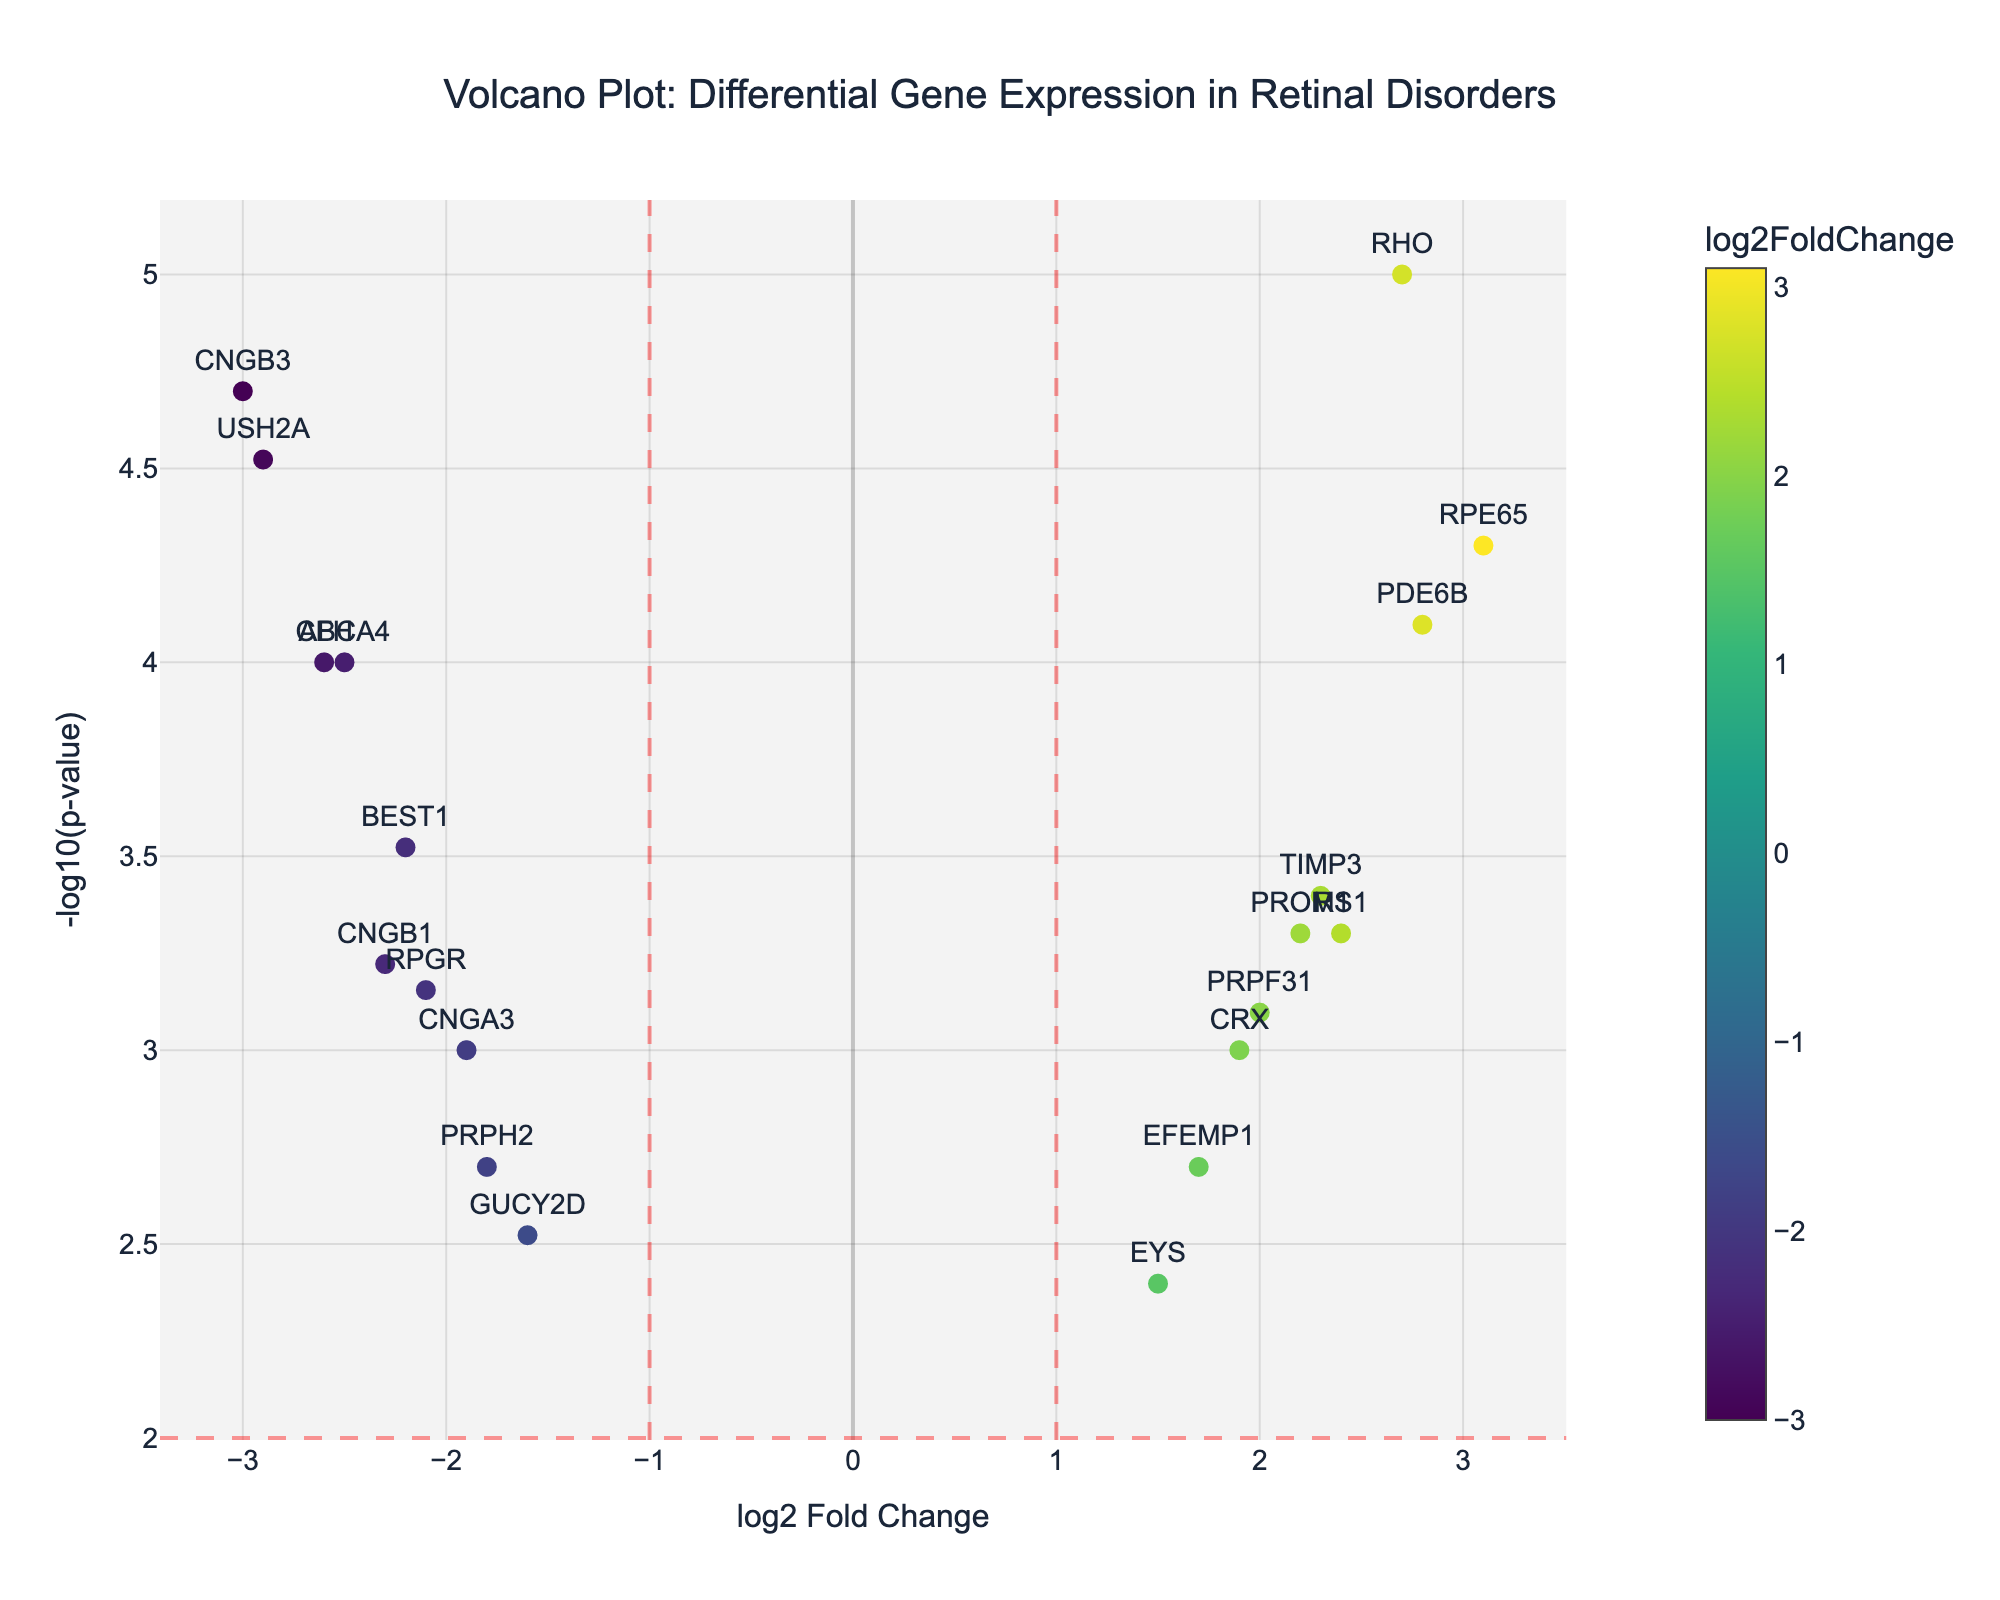What is the title of the plot? The title is prominently displayed at the top center of the plot. It provides a brief description of what the plot is about.
Answer: Volcano Plot: Differential Gene Expression in Retinal Disorders What are the labels of the x-axis and y-axis? The x-axis label is visible at the bottom of the plot, and the y-axis label is on the left side. They describe what each axis represents in the plot.
Answer: x-axis: log2 Fold Change, y-axis: -log10(p-value) How many genes have a log2 fold change greater than 2? Observing the x-axis, we count the number of data points that are beyond the value of 2.5 indicating genes whose log2 fold change lies above 2.
Answer: 5 Which gene has the highest -log10(p-value)? By looking for the highest point on the y-axis, which represents -log10(p-value), we can identify the corresponding gene from the labels.
Answer: RHO Which gene has the largest negative log2 fold change? We look to the far left of the x-axis and check which gene has the smallest (most negative) value.
Answer: CNGB3 How many genes are significantly differentially expressed (p-value < 0.01)? Significant genes can be identified by spotting data points above y = 2 (since -log10(0.01) = 2). We count the points above this value.
Answer: 14 Which gene has the smallest p-value? The smallest p-value corresponds to the highest -log10(p-value) value on the y-axis. Identify the gene at the highest y-value.
Answer: RHO What are the log2 fold change ranges for significantly upregulated and downregulated genes? Look at genes above y = 2. Then identify those to the right of x = 1 for upregulation and left of x = -1 for downregulation.
Answer: Upregulated: 1.9 to 3.1, Downregulated: -3.0 to -1.9 Which gene has a log2 fold change around zero but is still significantly differentially expressed? Find the data points that are close to x = 0 but are located above y = 2, then identify the corresponding gene.
Answer: CRX 